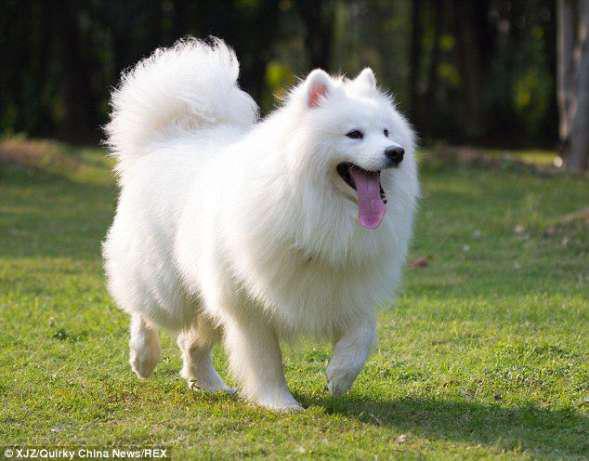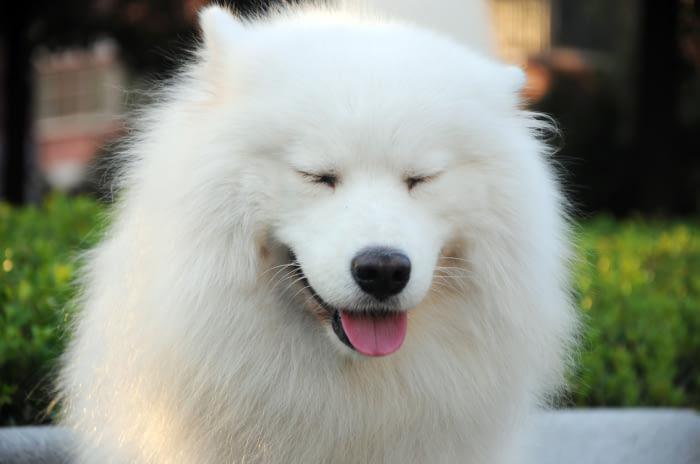The first image is the image on the left, the second image is the image on the right. Considering the images on both sides, is "There are two white dogs in each image that are roughly the same age." valid? Answer yes or no. No. The first image is the image on the left, the second image is the image on the right. Analyze the images presented: Is the assertion "Each image features two white dogs posed next to each other on green grass." valid? Answer yes or no. No. 